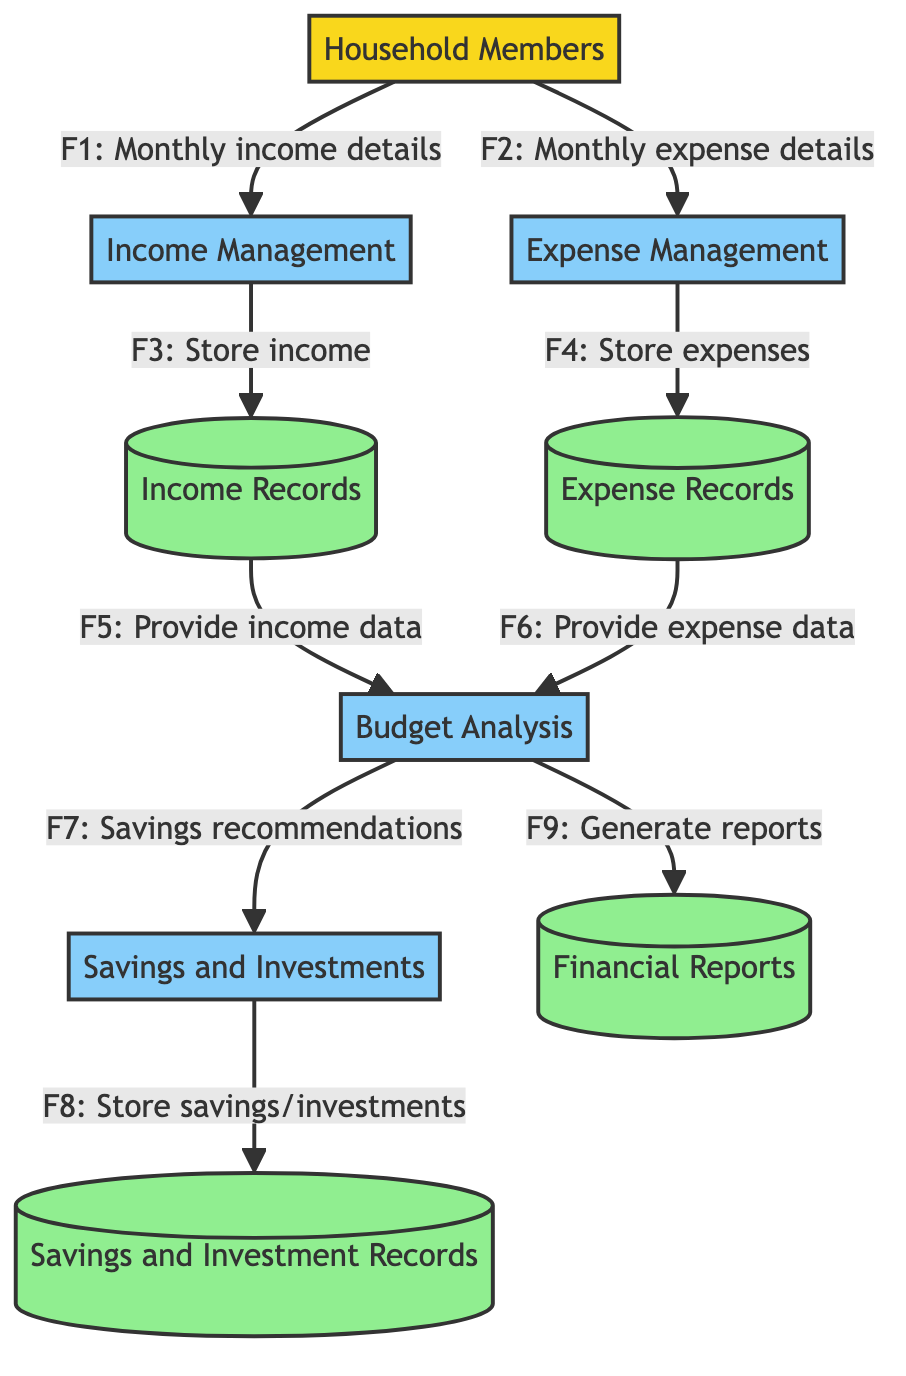What's the main external entity in this diagram? The only external entity represented in the diagram is "Household Members," which refers to the individuals in the family who provide income or determine expenses.
Answer: Household Members How many processes are depicted in this diagram? The diagram displays four processes, which are Income Management, Expense Management, Savings and Investments, and Budget Analysis.
Answer: Four What type of data store contains monthly income details? The data store that contains monthly income details is the "Income Records," which serves as a database for all income entries from household members.
Answer: Income Records Which process provides recommendations for savings and investments? The process that provides recommendations for savings and investments is the "Budget Analysis," which derives these recommendations based on the analysis of income and expenses.
Answer: Budget Analysis How many data flows connect Household Members to Income Management and Expense Management? There are two data flows connecting Household Members to processes: one for income details and another for expense details, specifically labeled F1 and F2 in the diagram.
Answer: Two What do the savings recommendations from Budget Analysis lead to? The recommendations for savings and investments derived from the Budget Analysis process lead to the "Savings and Investments" process, where savings and investment strategies are developed.
Answer: Savings and Investments Which data flow connects Expense Records to Budget Analysis? The data flow connecting Expense Records to Budget Analysis is labeled as F6, which signifies that expense data from the Expense Records is provided for analysis.
Answer: F6 What type of records are stored in "Savings and Investment Records"? The "Savings and Investment Records" data store is used to store details about all savings and investments made by the household, as indicated by the flow from the Savings and Investments process.
Answer: Savings and Investment Records How many data stores are present in the diagram? The diagram includes four data stores: Income Records, Expense Records, Savings and Investment Records, and Financial Reports, all of which play a role in managing household finances.
Answer: Four 